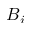<formula> <loc_0><loc_0><loc_500><loc_500>B _ { i }</formula> 